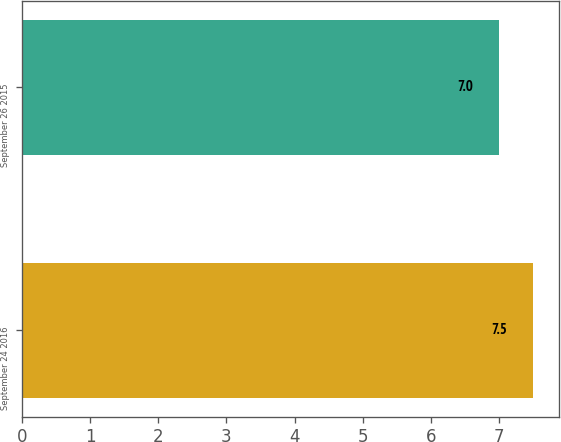Convert chart to OTSL. <chart><loc_0><loc_0><loc_500><loc_500><bar_chart><fcel>September 24 2016<fcel>September 26 2015<nl><fcel>7.5<fcel>7<nl></chart> 